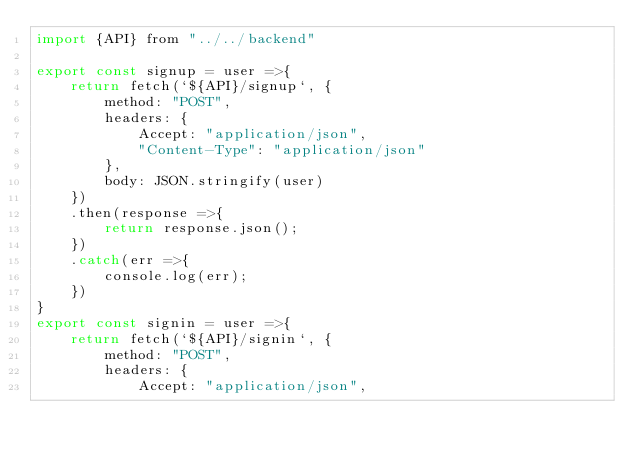<code> <loc_0><loc_0><loc_500><loc_500><_JavaScript_>import {API} from "../../backend"

export const signup = user =>{
    return fetch(`${API}/signup`, {
        method: "POST",
        headers: {
            Accept: "application/json",
            "Content-Type": "application/json"
        },
        body: JSON.stringify(user)
    })
    .then(response =>{
        return response.json();
    })
    .catch(err =>{
        console.log(err);
    })
}
export const signin = user =>{
    return fetch(`${API}/signin`, {
        method: "POST",
        headers: {
            Accept: "application/json",</code> 